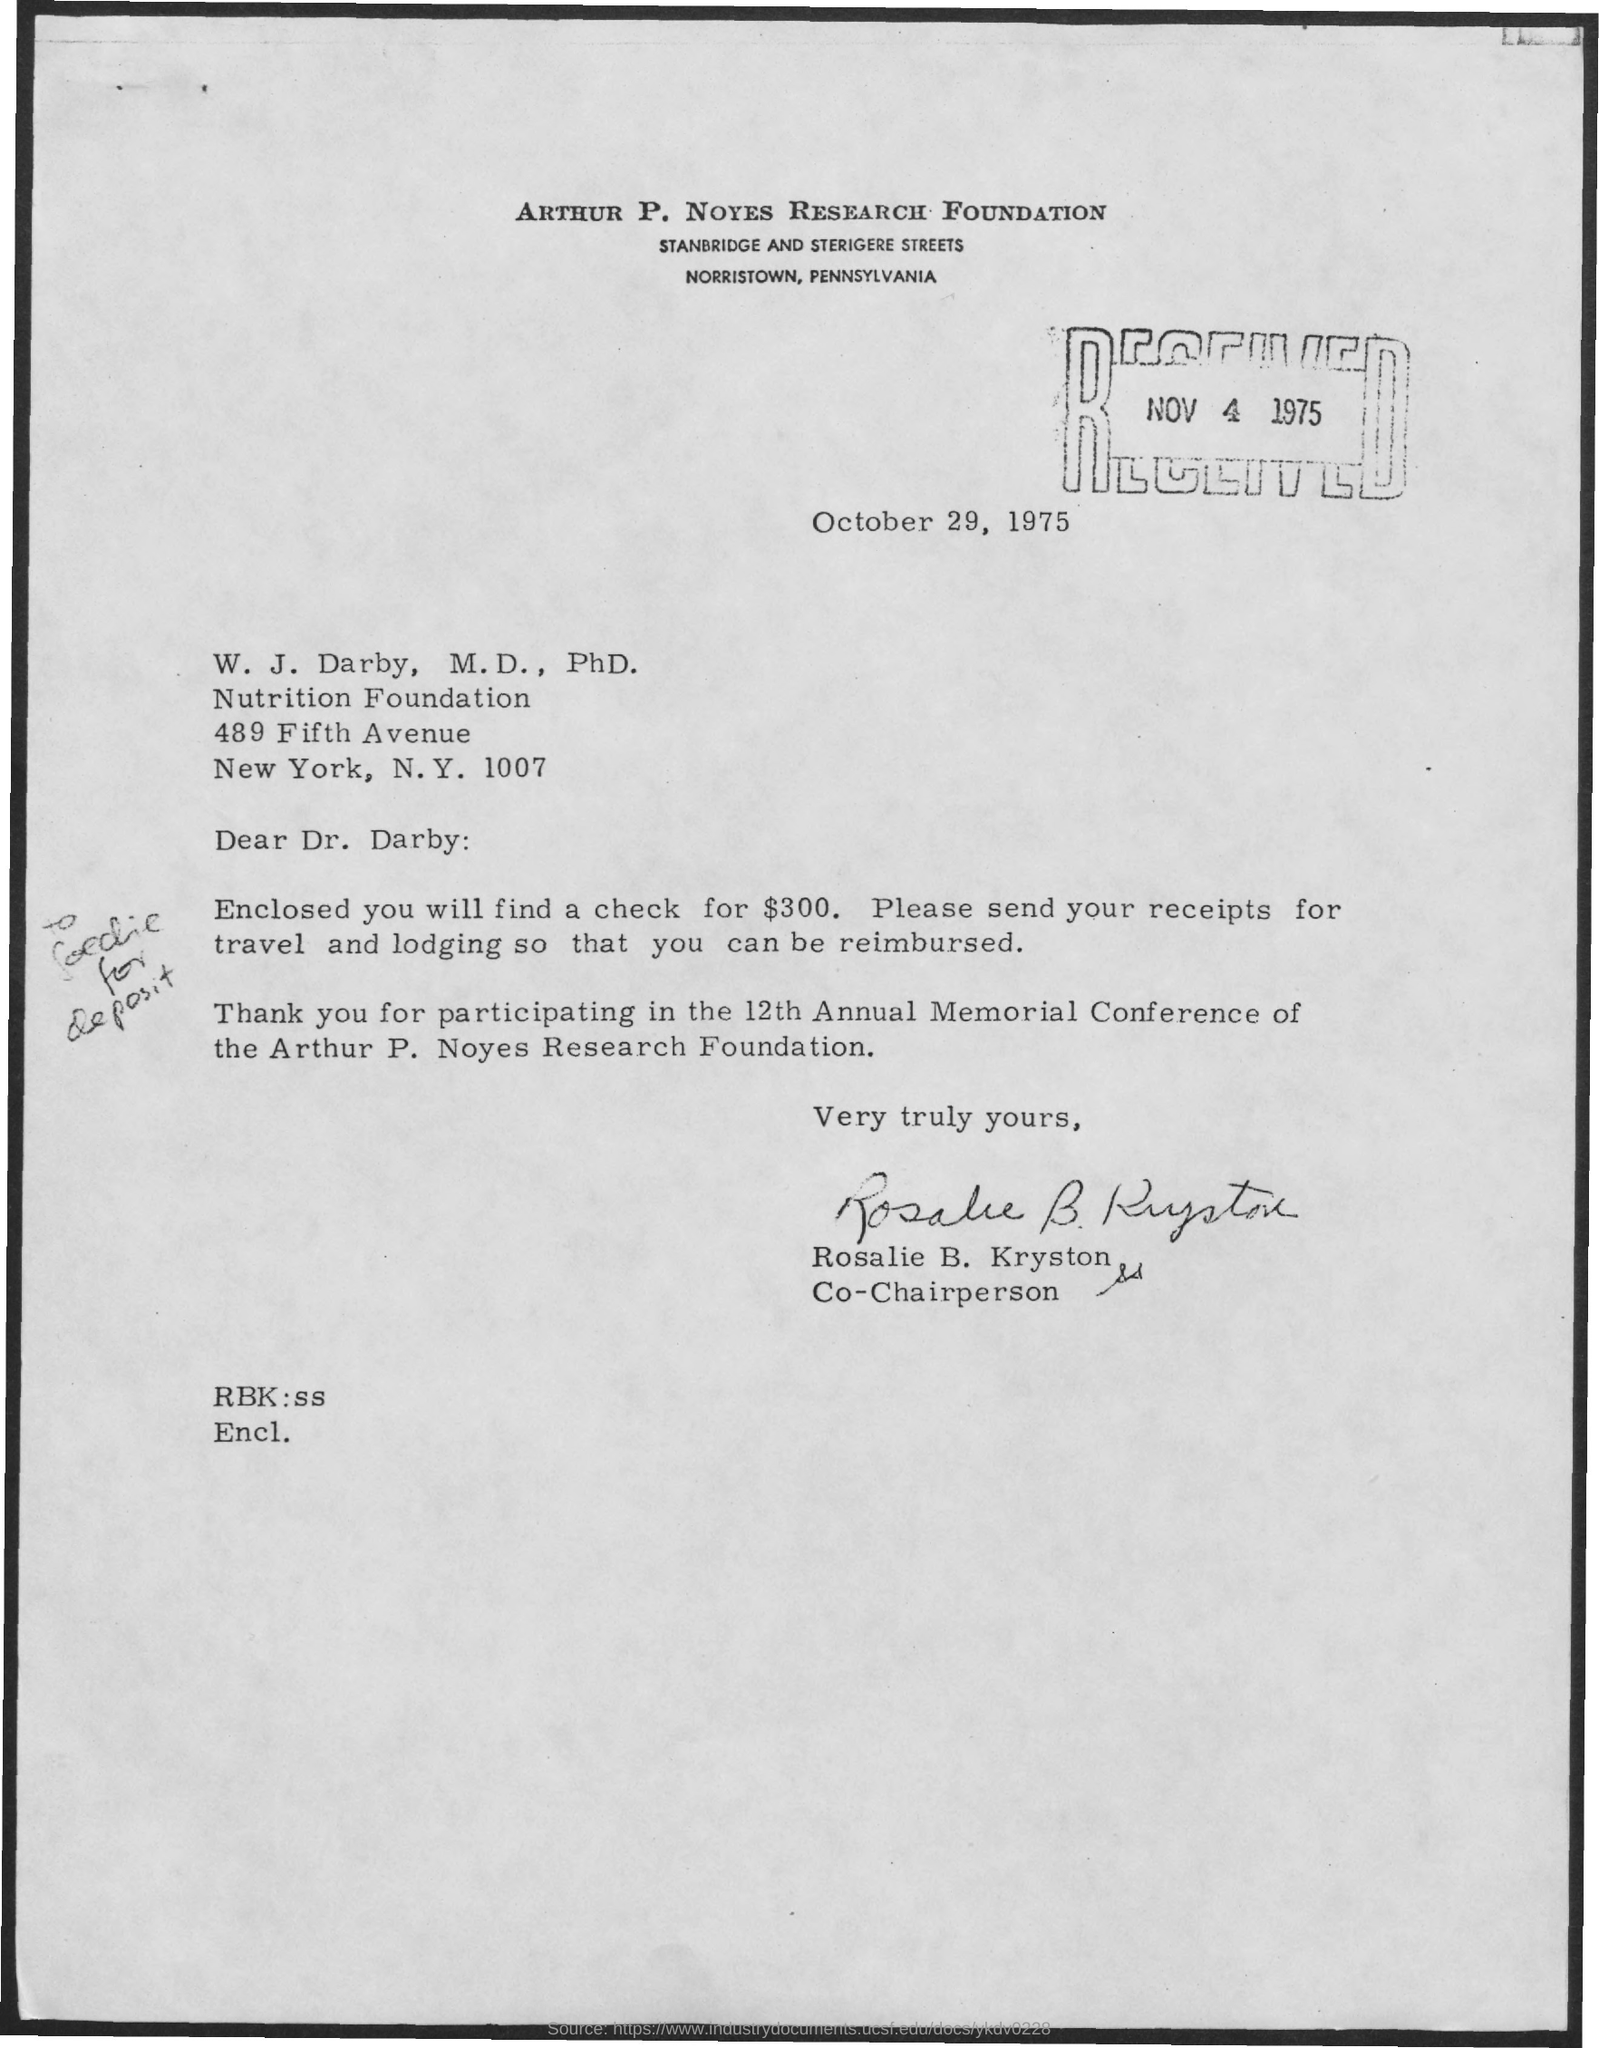What is the name of the research foundation?
Your answer should be compact. Arthur P. Noyes Research Foundation. Who is the co- chairperson ?
Offer a terse response. Rosalie B. Kryston. What is the amount in the cheque enclosed with letter?
Provide a short and direct response. $300. Who wrote this letter?
Ensure brevity in your answer.  Rosalie B. Kryston. 